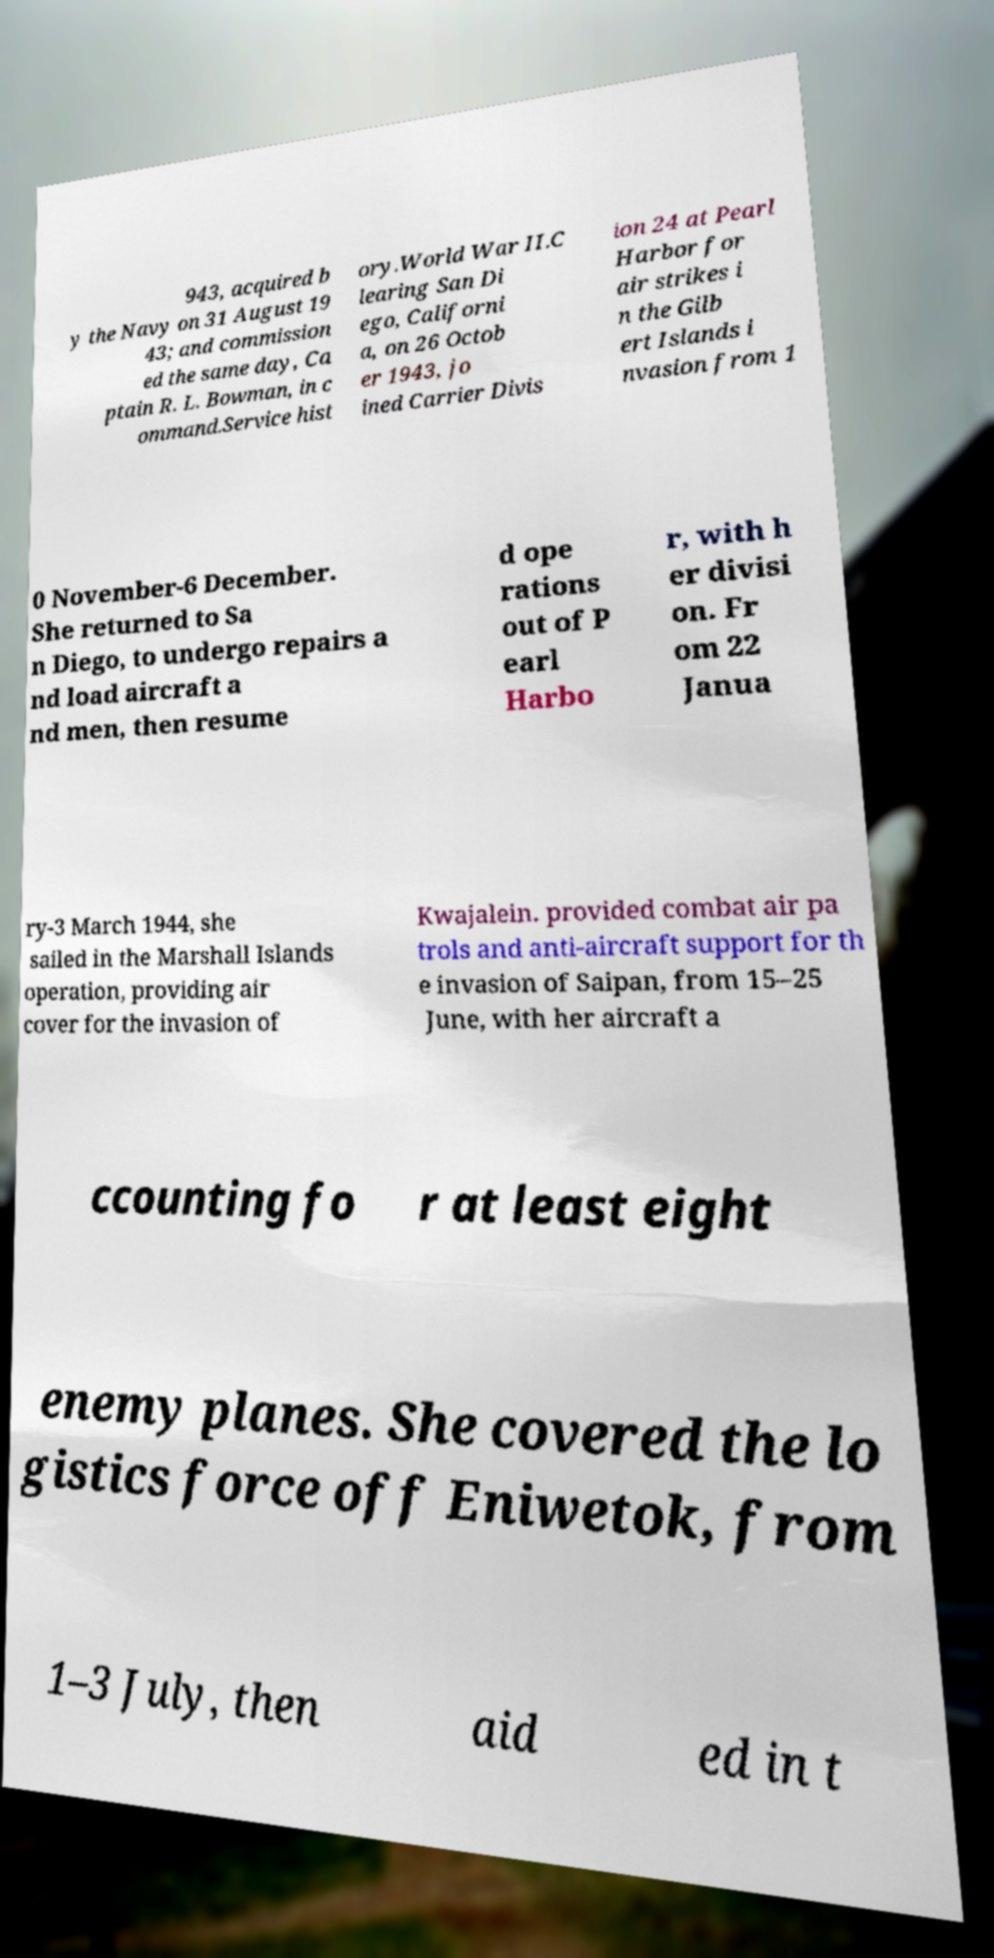For documentation purposes, I need the text within this image transcribed. Could you provide that? 943, acquired b y the Navy on 31 August 19 43; and commission ed the same day, Ca ptain R. L. Bowman, in c ommand.Service hist ory.World War II.C learing San Di ego, Californi a, on 26 Octob er 1943, jo ined Carrier Divis ion 24 at Pearl Harbor for air strikes i n the Gilb ert Islands i nvasion from 1 0 November-6 December. She returned to Sa n Diego, to undergo repairs a nd load aircraft a nd men, then resume d ope rations out of P earl Harbo r, with h er divisi on. Fr om 22 Janua ry-3 March 1944, she sailed in the Marshall Islands operation, providing air cover for the invasion of Kwajalein. provided combat air pa trols and anti-aircraft support for th e invasion of Saipan, from 15–25 June, with her aircraft a ccounting fo r at least eight enemy planes. She covered the lo gistics force off Eniwetok, from 1–3 July, then aid ed in t 